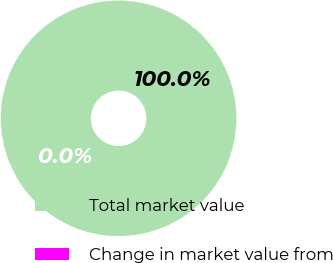Convert chart to OTSL. <chart><loc_0><loc_0><loc_500><loc_500><pie_chart><fcel>Total market value<fcel>Change in market value from<nl><fcel>100.0%<fcel>0.0%<nl></chart> 